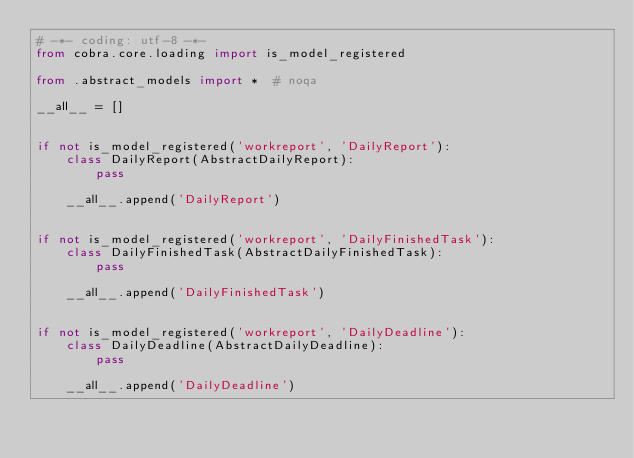<code> <loc_0><loc_0><loc_500><loc_500><_Python_># -*- coding: utf-8 -*-
from cobra.core.loading import is_model_registered

from .abstract_models import *  # noqa

__all__ = []


if not is_model_registered('workreport', 'DailyReport'):
    class DailyReport(AbstractDailyReport):
        pass

    __all__.append('DailyReport')


if not is_model_registered('workreport', 'DailyFinishedTask'):
    class DailyFinishedTask(AbstractDailyFinishedTask):
        pass

    __all__.append('DailyFinishedTask')


if not is_model_registered('workreport', 'DailyDeadline'):
    class DailyDeadline(AbstractDailyDeadline):
        pass

    __all__.append('DailyDeadline')

</code> 